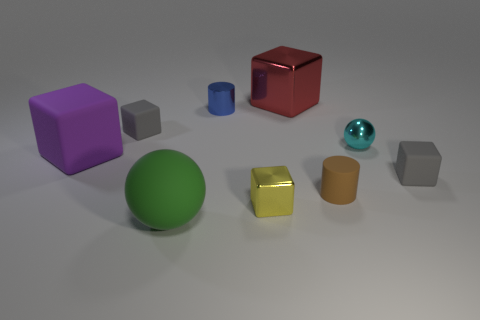How is lighting affecting the appearance of the objects? The lighting in the image creates soft shadows and highlights on the objects, enhancing their three-dimensional appearance. It appears to be diffused, likely from above, reducing harsh shadows and allowing the colors and textures of the objects to be clearly observed. 